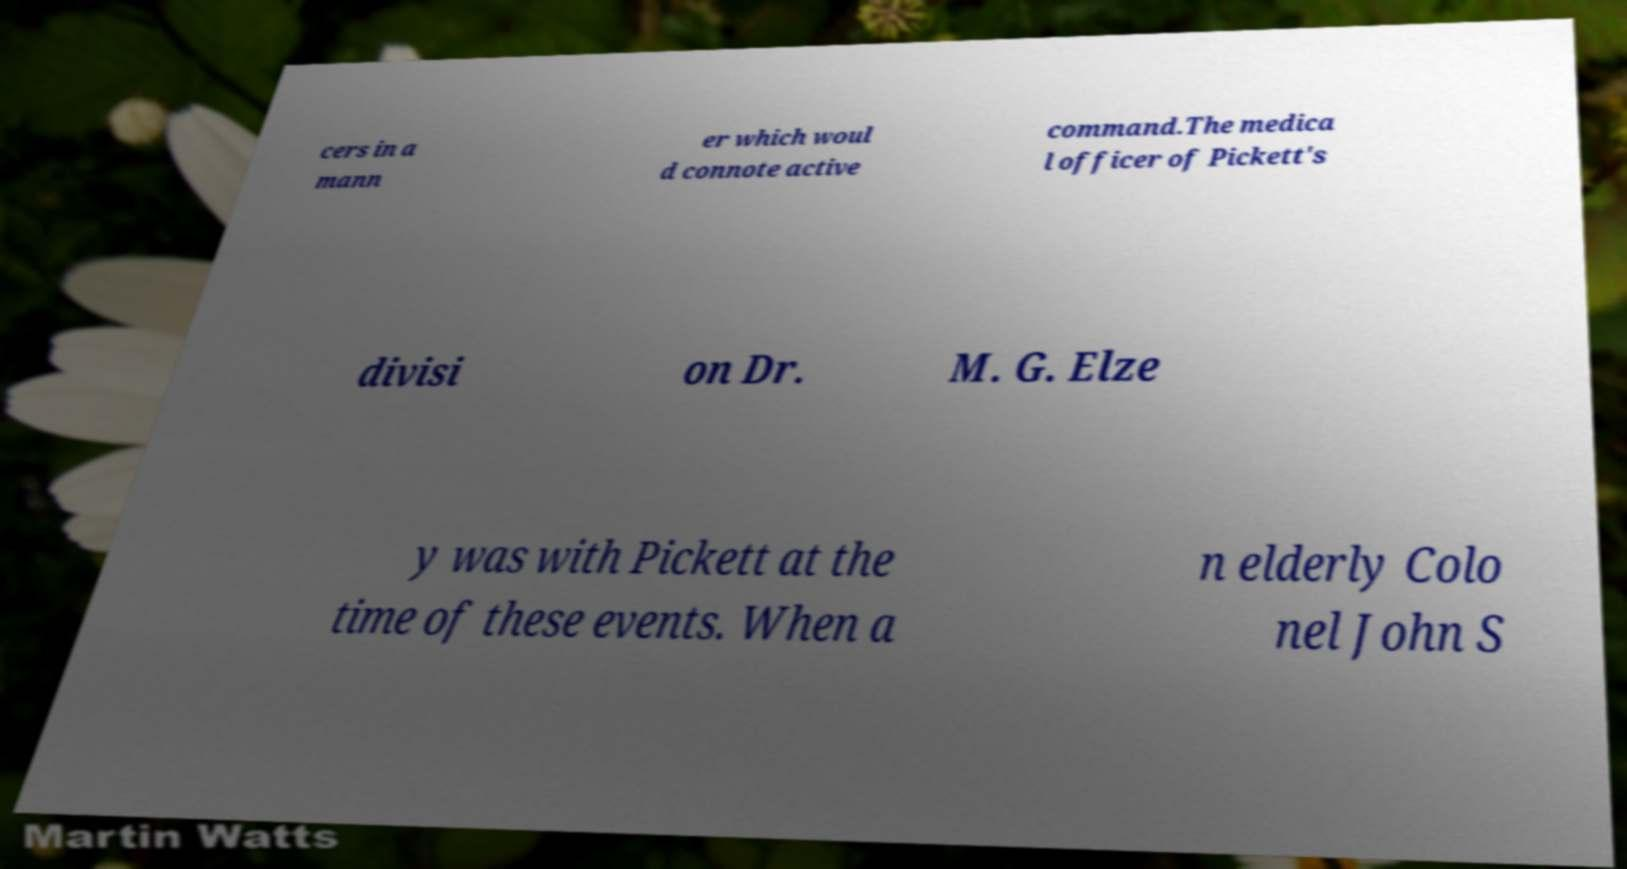Can you accurately transcribe the text from the provided image for me? cers in a mann er which woul d connote active command.The medica l officer of Pickett's divisi on Dr. M. G. Elze y was with Pickett at the time of these events. When a n elderly Colo nel John S 